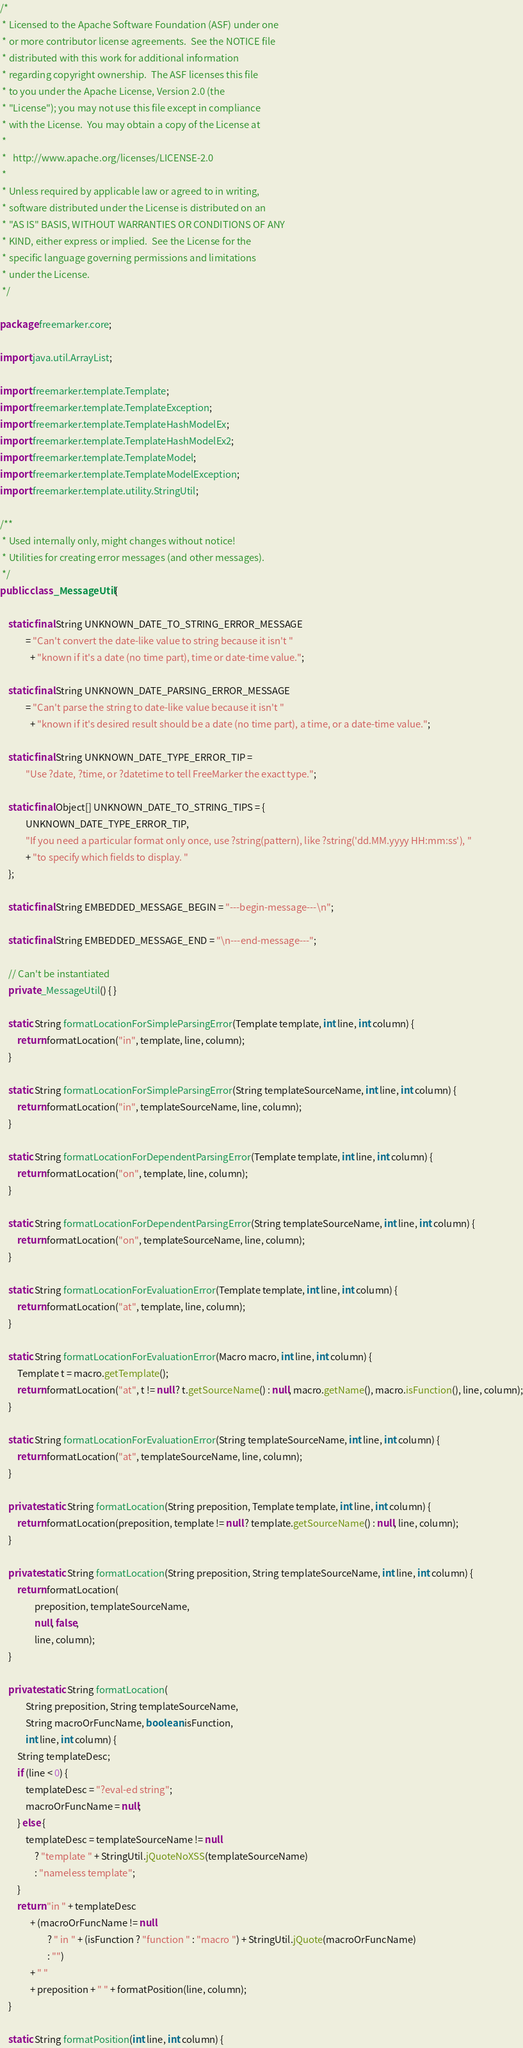Convert code to text. <code><loc_0><loc_0><loc_500><loc_500><_Java_>/*
 * Licensed to the Apache Software Foundation (ASF) under one
 * or more contributor license agreements.  See the NOTICE file
 * distributed with this work for additional information
 * regarding copyright ownership.  The ASF licenses this file
 * to you under the Apache License, Version 2.0 (the
 * "License"); you may not use this file except in compliance
 * with the License.  You may obtain a copy of the License at
 *
 *   http://www.apache.org/licenses/LICENSE-2.0
 *
 * Unless required by applicable law or agreed to in writing,
 * software distributed under the License is distributed on an
 * "AS IS" BASIS, WITHOUT WARRANTIES OR CONDITIONS OF ANY
 * KIND, either express or implied.  See the License for the
 * specific language governing permissions and limitations
 * under the License.
 */

package freemarker.core;

import java.util.ArrayList;

import freemarker.template.Template;
import freemarker.template.TemplateException;
import freemarker.template.TemplateHashModelEx;
import freemarker.template.TemplateHashModelEx2;
import freemarker.template.TemplateModel;
import freemarker.template.TemplateModelException;
import freemarker.template.utility.StringUtil;

/**
 * Used internally only, might changes without notice!
 * Utilities for creating error messages (and other messages).
 */
public class _MessageUtil {

    static final String UNKNOWN_DATE_TO_STRING_ERROR_MESSAGE
            = "Can't convert the date-like value to string because it isn't "
              + "known if it's a date (no time part), time or date-time value.";
    
    static final String UNKNOWN_DATE_PARSING_ERROR_MESSAGE
            = "Can't parse the string to date-like value because it isn't "
              + "known if it's desired result should be a date (no time part), a time, or a date-time value.";

    static final String UNKNOWN_DATE_TYPE_ERROR_TIP = 
            "Use ?date, ?time, or ?datetime to tell FreeMarker the exact type.";
    
    static final Object[] UNKNOWN_DATE_TO_STRING_TIPS = {
            UNKNOWN_DATE_TYPE_ERROR_TIP,
            "If you need a particular format only once, use ?string(pattern), like ?string('dd.MM.yyyy HH:mm:ss'), "
            + "to specify which fields to display. "
    };

    static final String EMBEDDED_MESSAGE_BEGIN = "---begin-message---\n";

    static final String EMBEDDED_MESSAGE_END = "\n---end-message---";

    // Can't be instantiated
    private _MessageUtil() { }
        
    static String formatLocationForSimpleParsingError(Template template, int line, int column) {
        return formatLocation("in", template, line, column);
    }

    static String formatLocationForSimpleParsingError(String templateSourceName, int line, int column) {
        return formatLocation("in", templateSourceName, line, column);
    }

    static String formatLocationForDependentParsingError(Template template, int line, int column) {
        return formatLocation("on", template, line, column);
    }

    static String formatLocationForDependentParsingError(String templateSourceName, int line, int column) {
        return formatLocation("on", templateSourceName, line, column);
    }

    static String formatLocationForEvaluationError(Template template, int line, int column) {
        return formatLocation("at", template, line, column);
    }

    static String formatLocationForEvaluationError(Macro macro, int line, int column) {
        Template t = macro.getTemplate();
        return formatLocation("at", t != null ? t.getSourceName() : null, macro.getName(), macro.isFunction(), line, column);
    }
    
    static String formatLocationForEvaluationError(String templateSourceName, int line, int column) {
        return formatLocation("at", templateSourceName, line, column);
    }

    private static String formatLocation(String preposition, Template template, int line, int column) {
        return formatLocation(preposition, template != null ? template.getSourceName() : null, line, column);
    }
    
    private static String formatLocation(String preposition, String templateSourceName, int line, int column) {
        return formatLocation(
                preposition, templateSourceName,
                null, false,
                line, column);
    }

    private static String formatLocation(
            String preposition, String templateSourceName,
            String macroOrFuncName, boolean isFunction,
            int line, int column) {
        String templateDesc;
        if (line < 0) {
            templateDesc = "?eval-ed string";
            macroOrFuncName = null;
        } else { 
            templateDesc = templateSourceName != null
                ? "template " + StringUtil.jQuoteNoXSS(templateSourceName)
                : "nameless template";
        }
        return "in " + templateDesc
              + (macroOrFuncName != null
                      ? " in " + (isFunction ? "function " : "macro ") + StringUtil.jQuote(macroOrFuncName)
                      : "")
              + " "
              + preposition + " " + formatPosition(line, column);
    }
    
    static String formatPosition(int line, int column) {</code> 